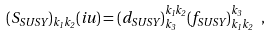Convert formula to latex. <formula><loc_0><loc_0><loc_500><loc_500>( S _ { S U S Y } ) _ { k _ { 1 } k _ { 2 } } ( i u ) = ( d _ { S U S Y } ) _ { k _ { 3 } } ^ { k _ { 1 } k _ { 2 } } ( f _ { S U S Y } ) _ { k _ { 1 } k _ { 2 } } ^ { k _ { 3 } } \ ,</formula> 